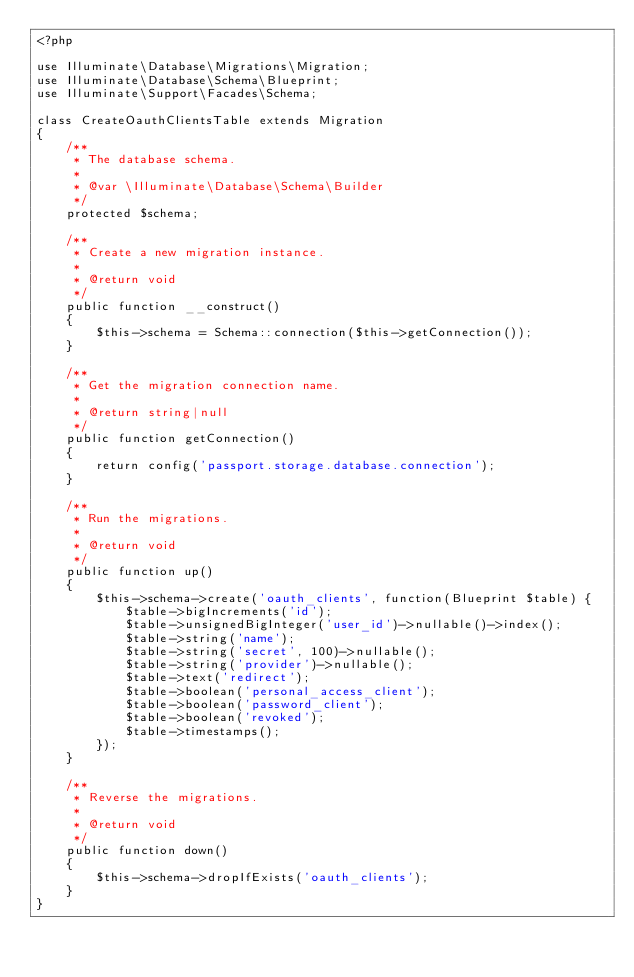<code> <loc_0><loc_0><loc_500><loc_500><_PHP_><?php

use Illuminate\Database\Migrations\Migration;
use Illuminate\Database\Schema\Blueprint;
use Illuminate\Support\Facades\Schema;

class CreateOauthClientsTable extends Migration
{
    /**
     * The database schema.
     *
     * @var \Illuminate\Database\Schema\Builder
     */
    protected $schema;

    /**
     * Create a new migration instance.
     *
     * @return void
     */
    public function __construct()
    {
        $this->schema = Schema::connection($this->getConnection());
    }

    /**
     * Get the migration connection name.
     *
     * @return string|null
     */
    public function getConnection()
    {
        return config('passport.storage.database.connection');
    }

    /**
     * Run the migrations.
     *
     * @return void
     */
    public function up()
    {
        $this->schema->create('oauth_clients', function(Blueprint $table) {
            $table->bigIncrements('id');
            $table->unsignedBigInteger('user_id')->nullable()->index();
            $table->string('name');
            $table->string('secret', 100)->nullable();
            $table->string('provider')->nullable();
            $table->text('redirect');
            $table->boolean('personal_access_client');
            $table->boolean('password_client');
            $table->boolean('revoked');
            $table->timestamps();
        });
    }

    /**
     * Reverse the migrations.
     *
     * @return void
     */
    public function down()
    {
        $this->schema->dropIfExists('oauth_clients');
    }
}
</code> 